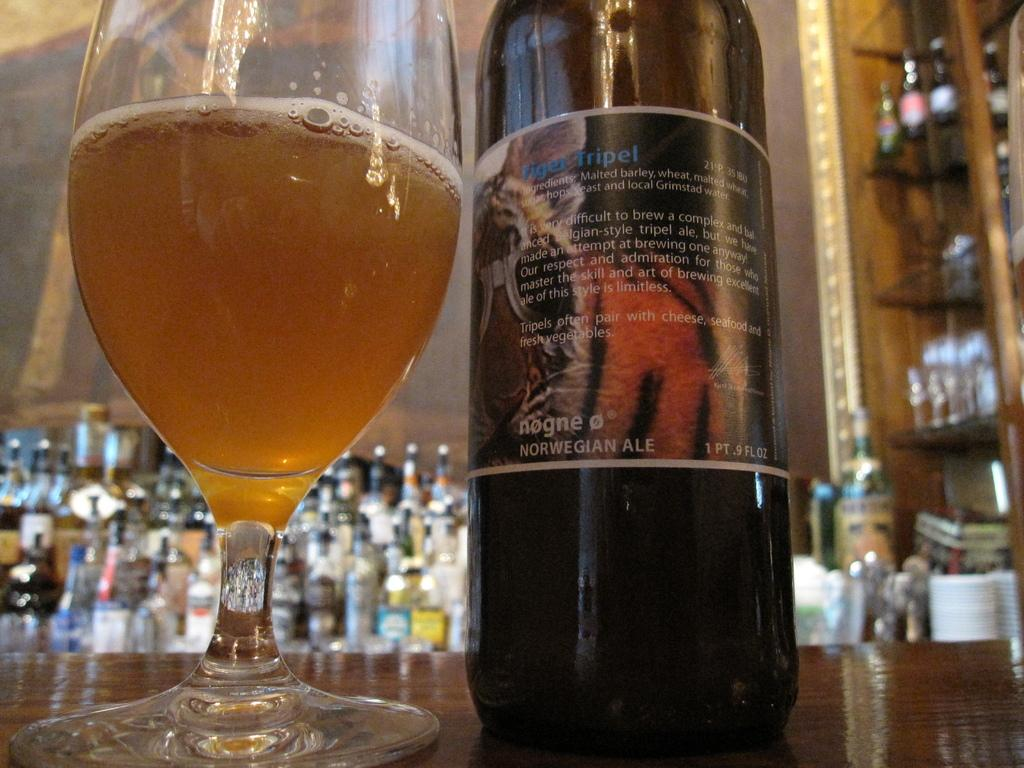<image>
Create a compact narrative representing the image presented. A bottle of Norwegian ale is on a table next to a glass. 